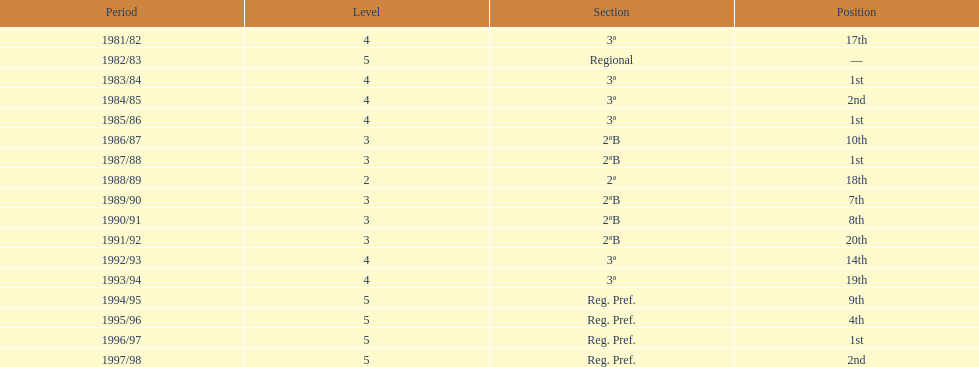Could you help me parse every detail presented in this table? {'header': ['Period', 'Level', 'Section', 'Position'], 'rows': [['1981/82', '4', '3ª', '17th'], ['1982/83', '5', 'Regional', '—'], ['1983/84', '4', '3ª', '1st'], ['1984/85', '4', '3ª', '2nd'], ['1985/86', '4', '3ª', '1st'], ['1986/87', '3', '2ªB', '10th'], ['1987/88', '3', '2ªB', '1st'], ['1988/89', '2', '2ª', '18th'], ['1989/90', '3', '2ªB', '7th'], ['1990/91', '3', '2ªB', '8th'], ['1991/92', '3', '2ªB', '20th'], ['1992/93', '4', '3ª', '14th'], ['1993/94', '4', '3ª', '19th'], ['1994/95', '5', 'Reg. Pref.', '9th'], ['1995/96', '5', 'Reg. Pref.', '4th'], ['1996/97', '5', 'Reg. Pref.', '1st'], ['1997/98', '5', 'Reg. Pref.', '2nd']]} Which tier was ud alzira a part of the least? 2. 